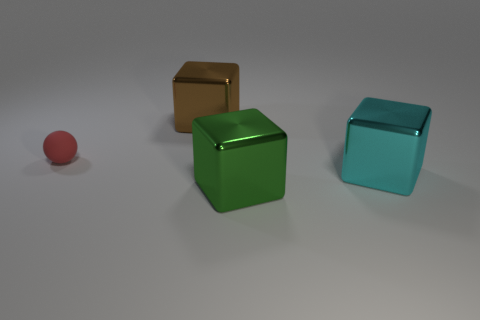Add 4 cyan metallic objects. How many objects exist? 8 Subtract all cubes. How many objects are left? 1 Subtract 0 purple cylinders. How many objects are left? 4 Subtract all cyan shiny objects. Subtract all cyan rubber spheres. How many objects are left? 3 Add 3 small matte spheres. How many small matte spheres are left? 4 Add 4 green shiny cubes. How many green shiny cubes exist? 5 